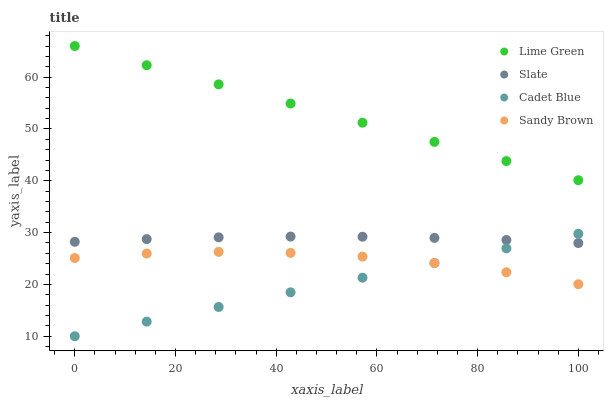Does Cadet Blue have the minimum area under the curve?
Answer yes or no. Yes. Does Lime Green have the maximum area under the curve?
Answer yes or no. Yes. Does Slate have the minimum area under the curve?
Answer yes or no. No. Does Slate have the maximum area under the curve?
Answer yes or no. No. Is Lime Green the smoothest?
Answer yes or no. Yes. Is Sandy Brown the roughest?
Answer yes or no. Yes. Is Slate the smoothest?
Answer yes or no. No. Is Slate the roughest?
Answer yes or no. No. Does Cadet Blue have the lowest value?
Answer yes or no. Yes. Does Slate have the lowest value?
Answer yes or no. No. Does Lime Green have the highest value?
Answer yes or no. Yes. Does Slate have the highest value?
Answer yes or no. No. Is Sandy Brown less than Slate?
Answer yes or no. Yes. Is Lime Green greater than Slate?
Answer yes or no. Yes. Does Cadet Blue intersect Sandy Brown?
Answer yes or no. Yes. Is Cadet Blue less than Sandy Brown?
Answer yes or no. No. Is Cadet Blue greater than Sandy Brown?
Answer yes or no. No. Does Sandy Brown intersect Slate?
Answer yes or no. No. 